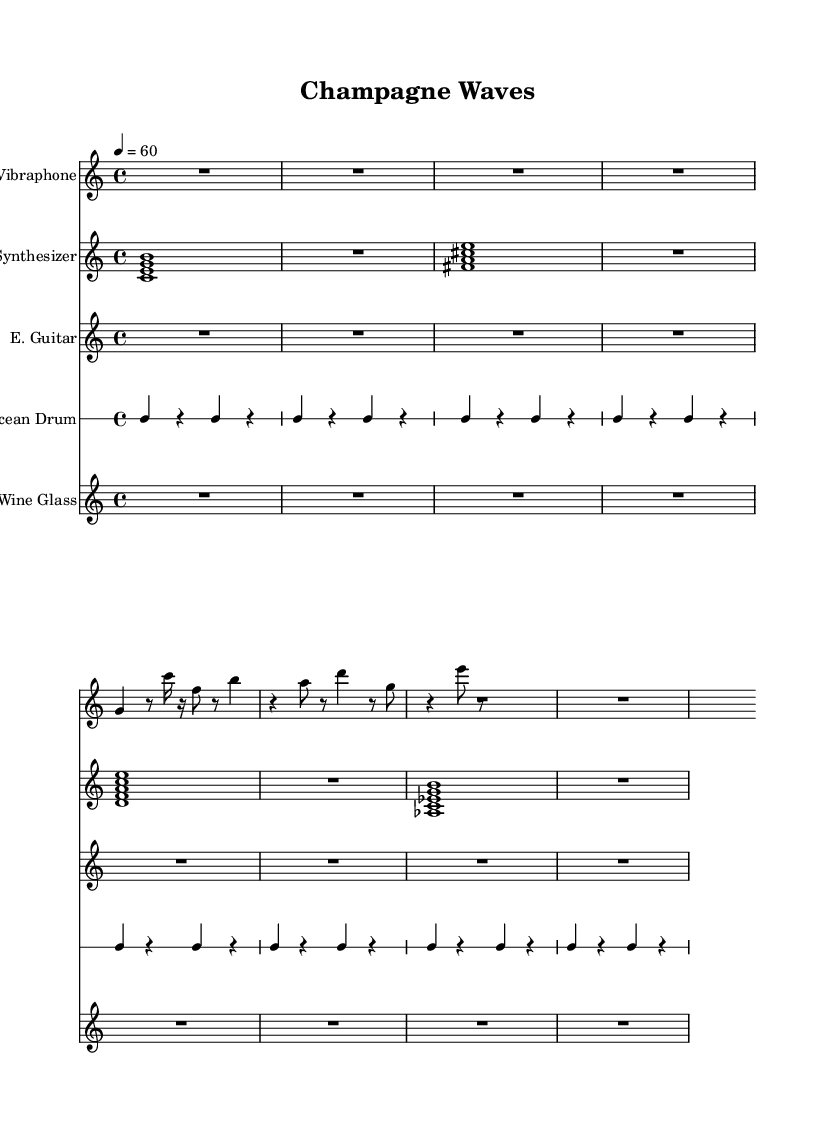What is the title of this music? The title is clearly indicated at the top of the sheet music under the header section.
Answer: Champagne Waves What is the tempo marking indicated in the score? The tempo marking shows '4 = 60,' which means the quarter note has a tempo value of 60 beats per minute.
Answer: 60 What is the time signature of this piece? The time signature is shown as '4/4' at the beginning of the score, indicating four beats per measure and a quarter note receives one beat.
Answer: 4/4 How many measures are in the vibraphone part? Counting the measures in the vibraphone part, there are a total of six measures visible.
Answer: Six Which instrument plays a repeating pattern in this score? The Ocean Drum is specified to have a repeating pattern indicated by the 'repeat unfold 8' directive, showing it maintains a consistent rhythm.
Answer: Ocean Drum What is the duration of the first note in the synth part? In the synth part, the first note is a whole note, indicated by the notation which takes up the full measure, suggesting it lasts for four beats.
Answer: Whole note How many different instruments are featured in this composition? Observing the score, there are five different instruments: Vibraphone, Synthesizer, E. Guitar, Ocean Drum, and Wine Glass, each with its own staff.
Answer: Five 